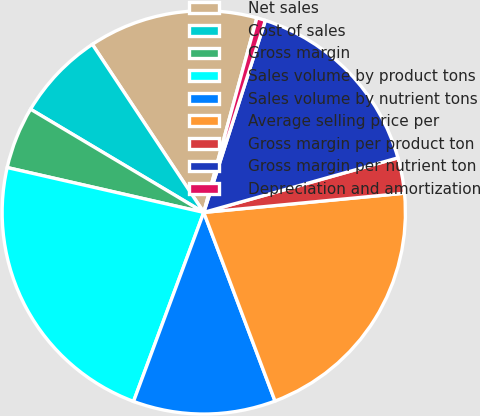Convert chart to OTSL. <chart><loc_0><loc_0><loc_500><loc_500><pie_chart><fcel>Net sales<fcel>Cost of sales<fcel>Gross margin<fcel>Sales volume by product tons<fcel>Sales volume by nutrient tons<fcel>Average selling price per<fcel>Gross margin per product ton<fcel>Gross margin per nutrient ton<fcel>Depreciation and amortization<nl><fcel>13.56%<fcel>7.13%<fcel>4.98%<fcel>22.91%<fcel>11.41%<fcel>20.77%<fcel>2.84%<fcel>15.7%<fcel>0.7%<nl></chart> 